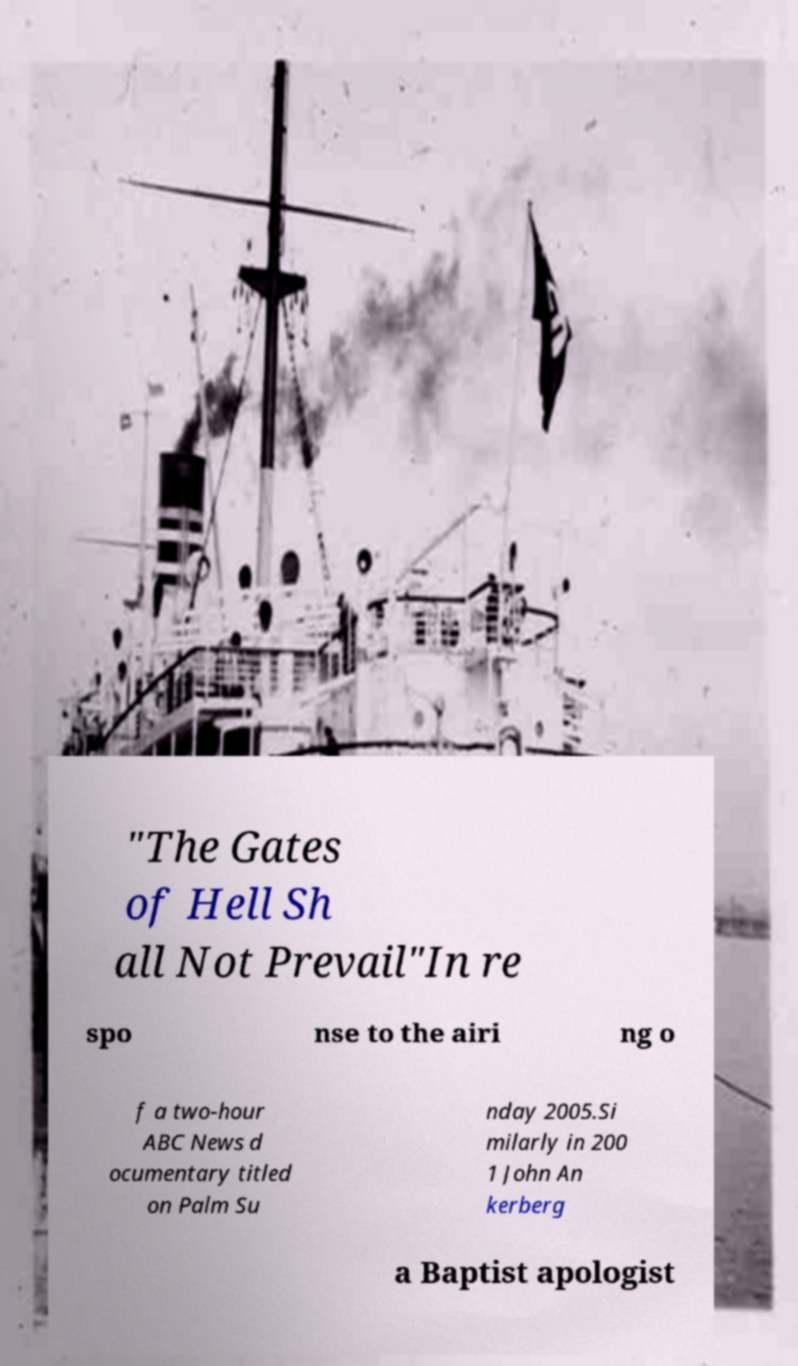Could you assist in decoding the text presented in this image and type it out clearly? "The Gates of Hell Sh all Not Prevail"In re spo nse to the airi ng o f a two-hour ABC News d ocumentary titled on Palm Su nday 2005.Si milarly in 200 1 John An kerberg a Baptist apologist 